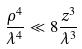Convert formula to latex. <formula><loc_0><loc_0><loc_500><loc_500>\frac { \rho ^ { 4 } } { \lambda ^ { 4 } } \ll 8 \frac { z ^ { 3 } } { \lambda ^ { 3 } }</formula> 